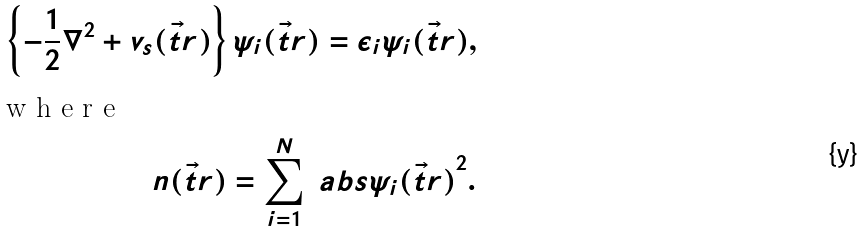Convert formula to latex. <formula><loc_0><loc_0><loc_500><loc_500>\left \{ - \frac { 1 } { 2 } \nabla ^ { 2 } + v _ { s } ( \vec { t } { r } ) \right \} \psi _ { i } ( \vec { t } { r } ) = \epsilon _ { i } \psi _ { i } ( \vec { t } { r } ) , \\ \intertext { w h e r e } n ( \vec { t } { r } ) = \sum _ { i = 1 } ^ { N } \ a b s { \psi _ { i } ( \vec { t } { r } ) } ^ { 2 } .</formula> 